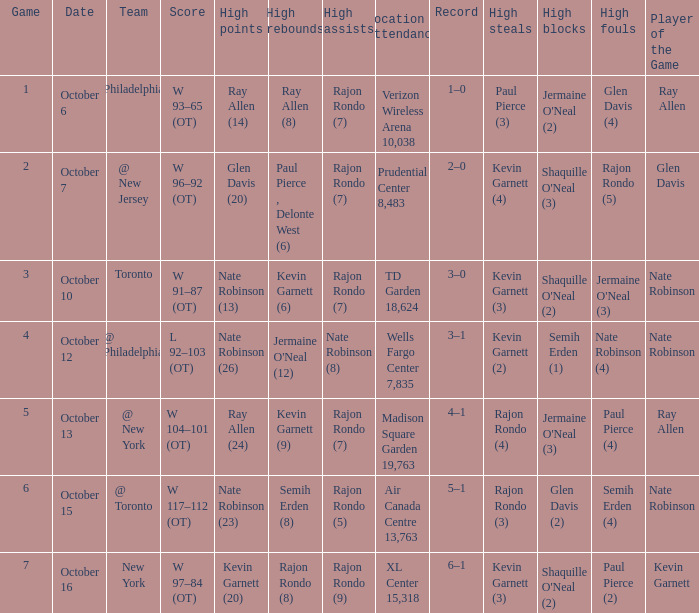Who obtained the greatest number of assists and how many were there on october 7? Rajon Rondo (7). 